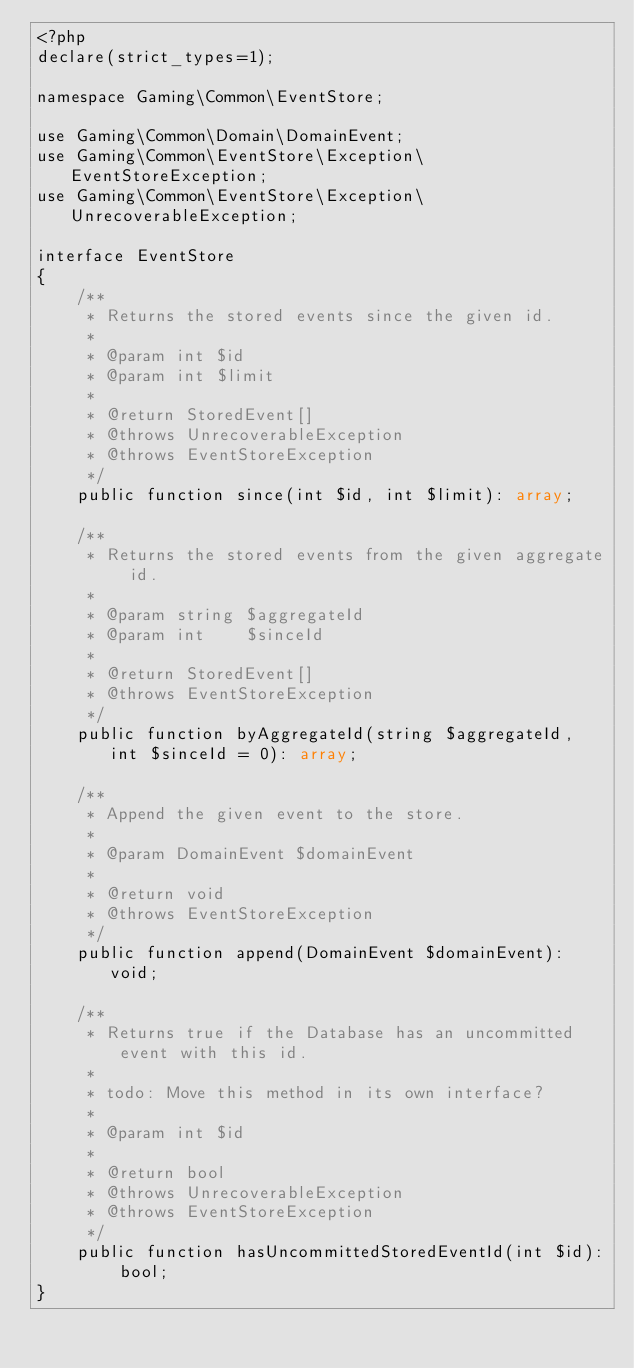Convert code to text. <code><loc_0><loc_0><loc_500><loc_500><_PHP_><?php
declare(strict_types=1);

namespace Gaming\Common\EventStore;

use Gaming\Common\Domain\DomainEvent;
use Gaming\Common\EventStore\Exception\EventStoreException;
use Gaming\Common\EventStore\Exception\UnrecoverableException;

interface EventStore
{
    /**
     * Returns the stored events since the given id.
     *
     * @param int $id
     * @param int $limit
     *
     * @return StoredEvent[]
     * @throws UnrecoverableException
     * @throws EventStoreException
     */
    public function since(int $id, int $limit): array;

    /**
     * Returns the stored events from the given aggregate id.
     *
     * @param string $aggregateId
     * @param int    $sinceId
     *
     * @return StoredEvent[]
     * @throws EventStoreException
     */
    public function byAggregateId(string $aggregateId, int $sinceId = 0): array;

    /**
     * Append the given event to the store.
     *
     * @param DomainEvent $domainEvent
     *
     * @return void
     * @throws EventStoreException
     */
    public function append(DomainEvent $domainEvent): void;

    /**
     * Returns true if the Database has an uncommitted event with this id.
     *
     * todo: Move this method in its own interface?
     *
     * @param int $id
     *
     * @return bool
     * @throws UnrecoverableException
     * @throws EventStoreException
     */
    public function hasUncommittedStoredEventId(int $id): bool;
}
</code> 